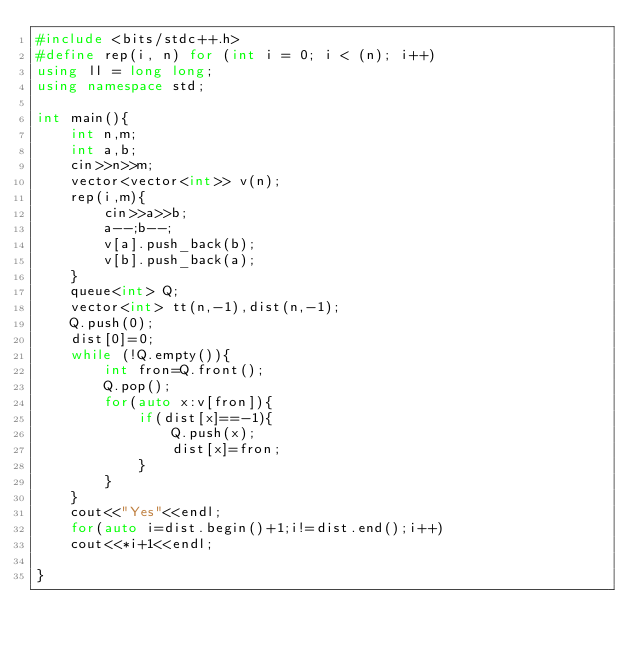<code> <loc_0><loc_0><loc_500><loc_500><_C++_>#include <bits/stdc++.h>
#define rep(i, n) for (int i = 0; i < (n); i++)
using ll = long long;
using namespace std;

int main(){
    int n,m;
    int a,b;
    cin>>n>>m;
    vector<vector<int>> v(n);
    rep(i,m){
        cin>>a>>b;
        a--;b--;
        v[a].push_back(b);
        v[b].push_back(a);
    }
    queue<int> Q;
    vector<int> tt(n,-1),dist(n,-1);
    Q.push(0);
    dist[0]=0;
    while (!Q.empty()){
        int fron=Q.front();
        Q.pop();
        for(auto x:v[fron]){
            if(dist[x]==-1){
                Q.push(x);
                dist[x]=fron;
            }
        }
    }
    cout<<"Yes"<<endl;
    for(auto i=dist.begin()+1;i!=dist.end();i++)
    cout<<*i+1<<endl;
    
}

</code> 